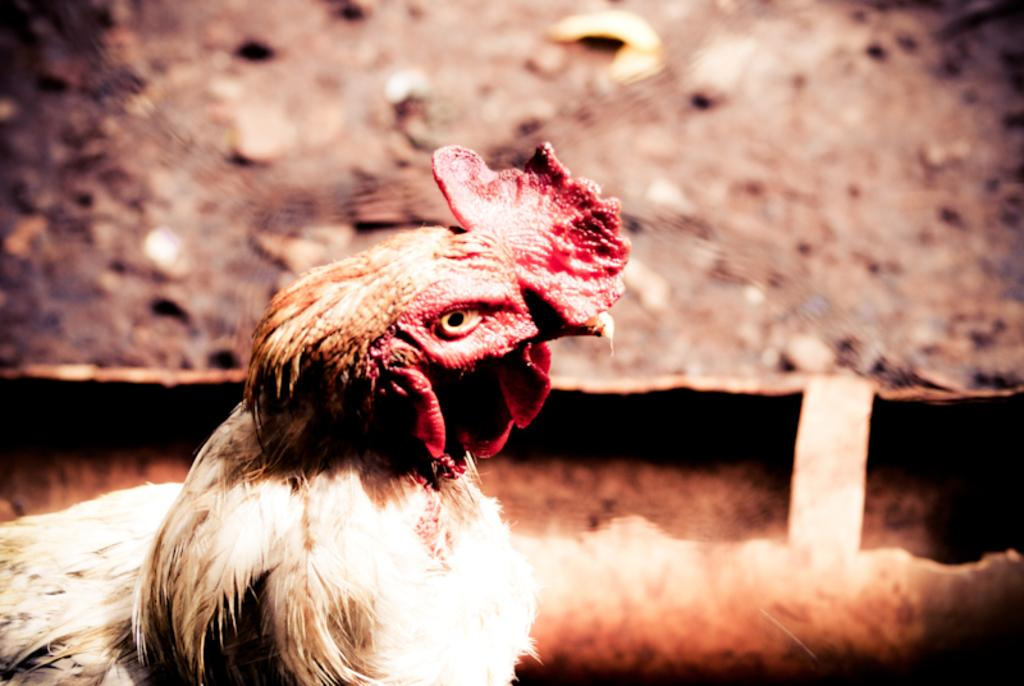What type of animal is present in the image? There is a hen in the picture. What can be seen in the background of the image? There is a wall visible in the picture. What songs is the hen singing in the picture? There is no indication that the hen is singing songs in the image. 